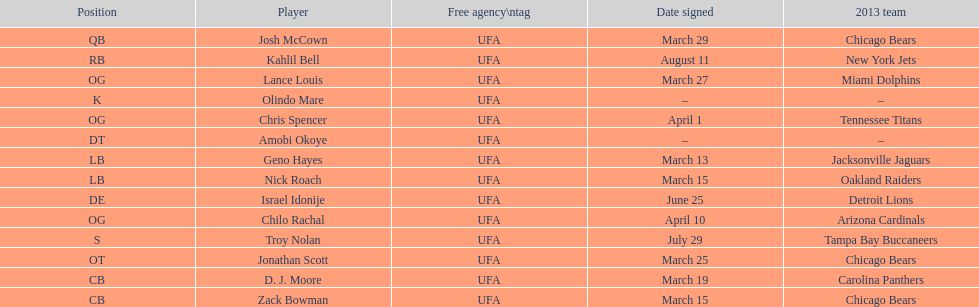His/her first name is the same name as a country. Israel Idonije. 